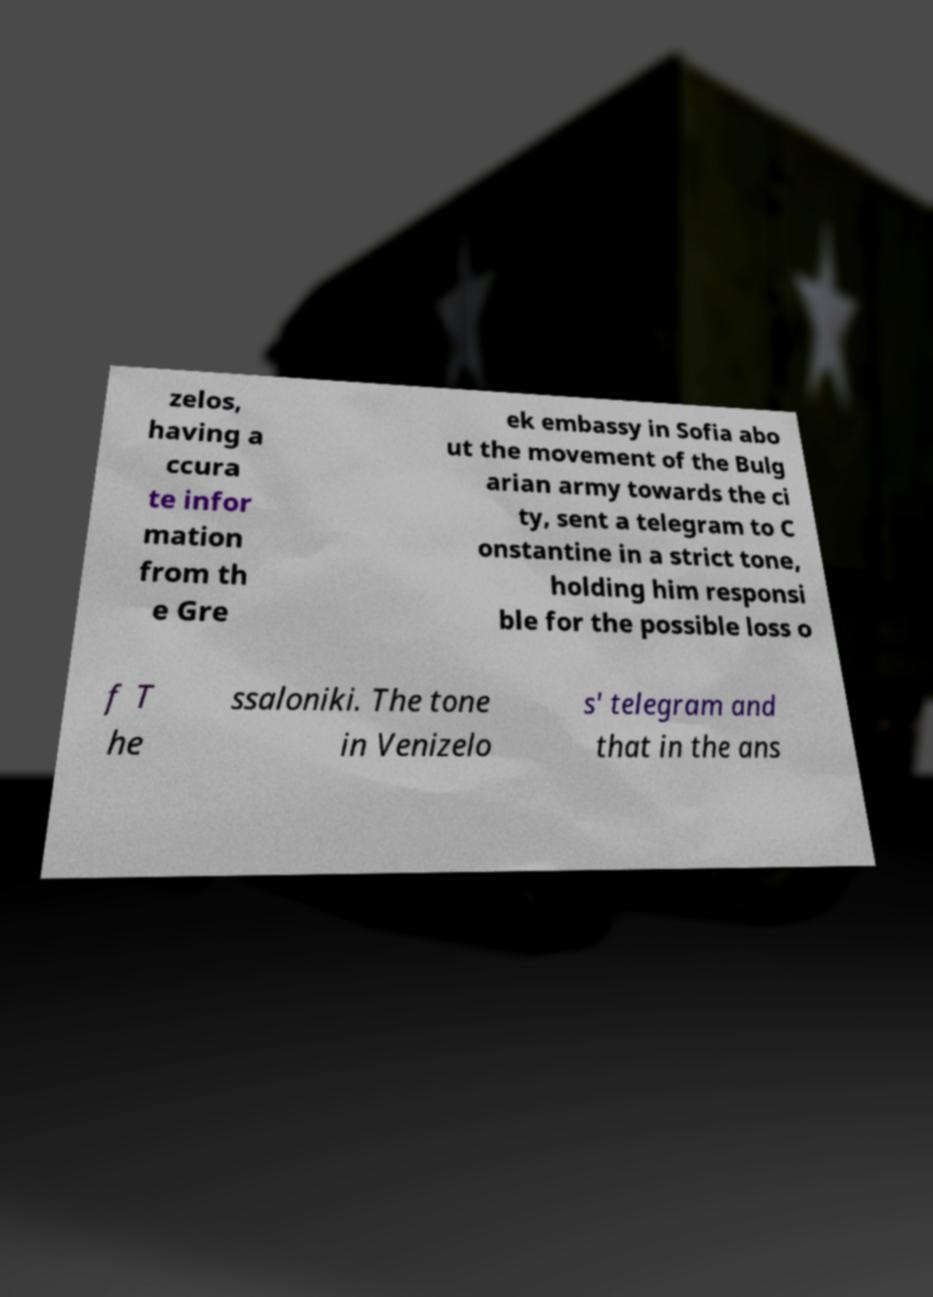Please read and relay the text visible in this image. What does it say? zelos, having a ccura te infor mation from th e Gre ek embassy in Sofia abo ut the movement of the Bulg arian army towards the ci ty, sent a telegram to C onstantine in a strict tone, holding him responsi ble for the possible loss o f T he ssaloniki. The tone in Venizelo s' telegram and that in the ans 